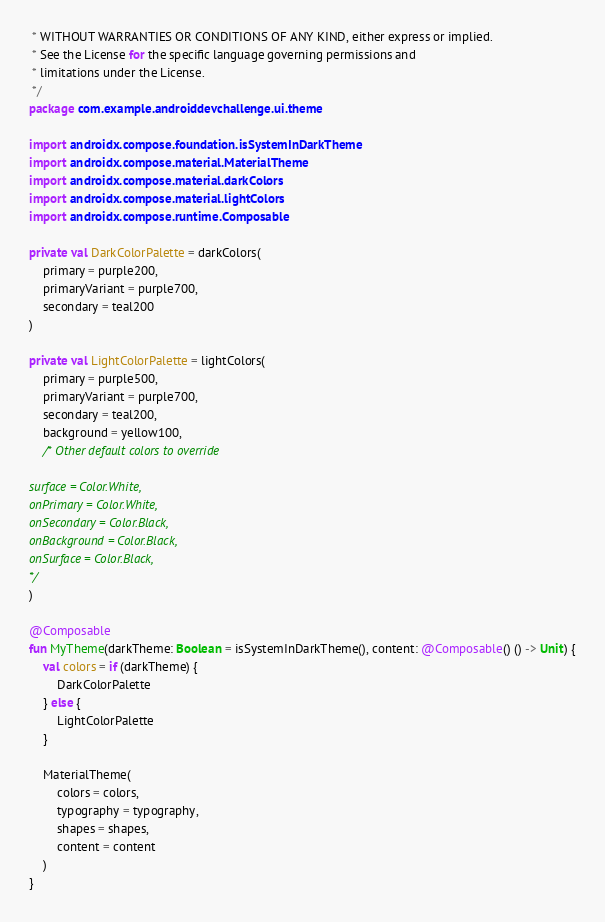<code> <loc_0><loc_0><loc_500><loc_500><_Kotlin_> * WITHOUT WARRANTIES OR CONDITIONS OF ANY KIND, either express or implied.
 * See the License for the specific language governing permissions and
 * limitations under the License.
 */
package com.example.androiddevchallenge.ui.theme

import androidx.compose.foundation.isSystemInDarkTheme
import androidx.compose.material.MaterialTheme
import androidx.compose.material.darkColors
import androidx.compose.material.lightColors
import androidx.compose.runtime.Composable

private val DarkColorPalette = darkColors(
    primary = purple200,
    primaryVariant = purple700,
    secondary = teal200
)

private val LightColorPalette = lightColors(
    primary = purple500,
    primaryVariant = purple700,
    secondary = teal200,
    background = yellow100,
    /* Other default colors to override

surface = Color.White,
onPrimary = Color.White,
onSecondary = Color.Black,
onBackground = Color.Black,
onSurface = Color.Black,
*/
)

@Composable
fun MyTheme(darkTheme: Boolean = isSystemInDarkTheme(), content: @Composable() () -> Unit) {
    val colors = if (darkTheme) {
        DarkColorPalette
    } else {
        LightColorPalette
    }

    MaterialTheme(
        colors = colors,
        typography = typography,
        shapes = shapes,
        content = content
    )
}
</code> 